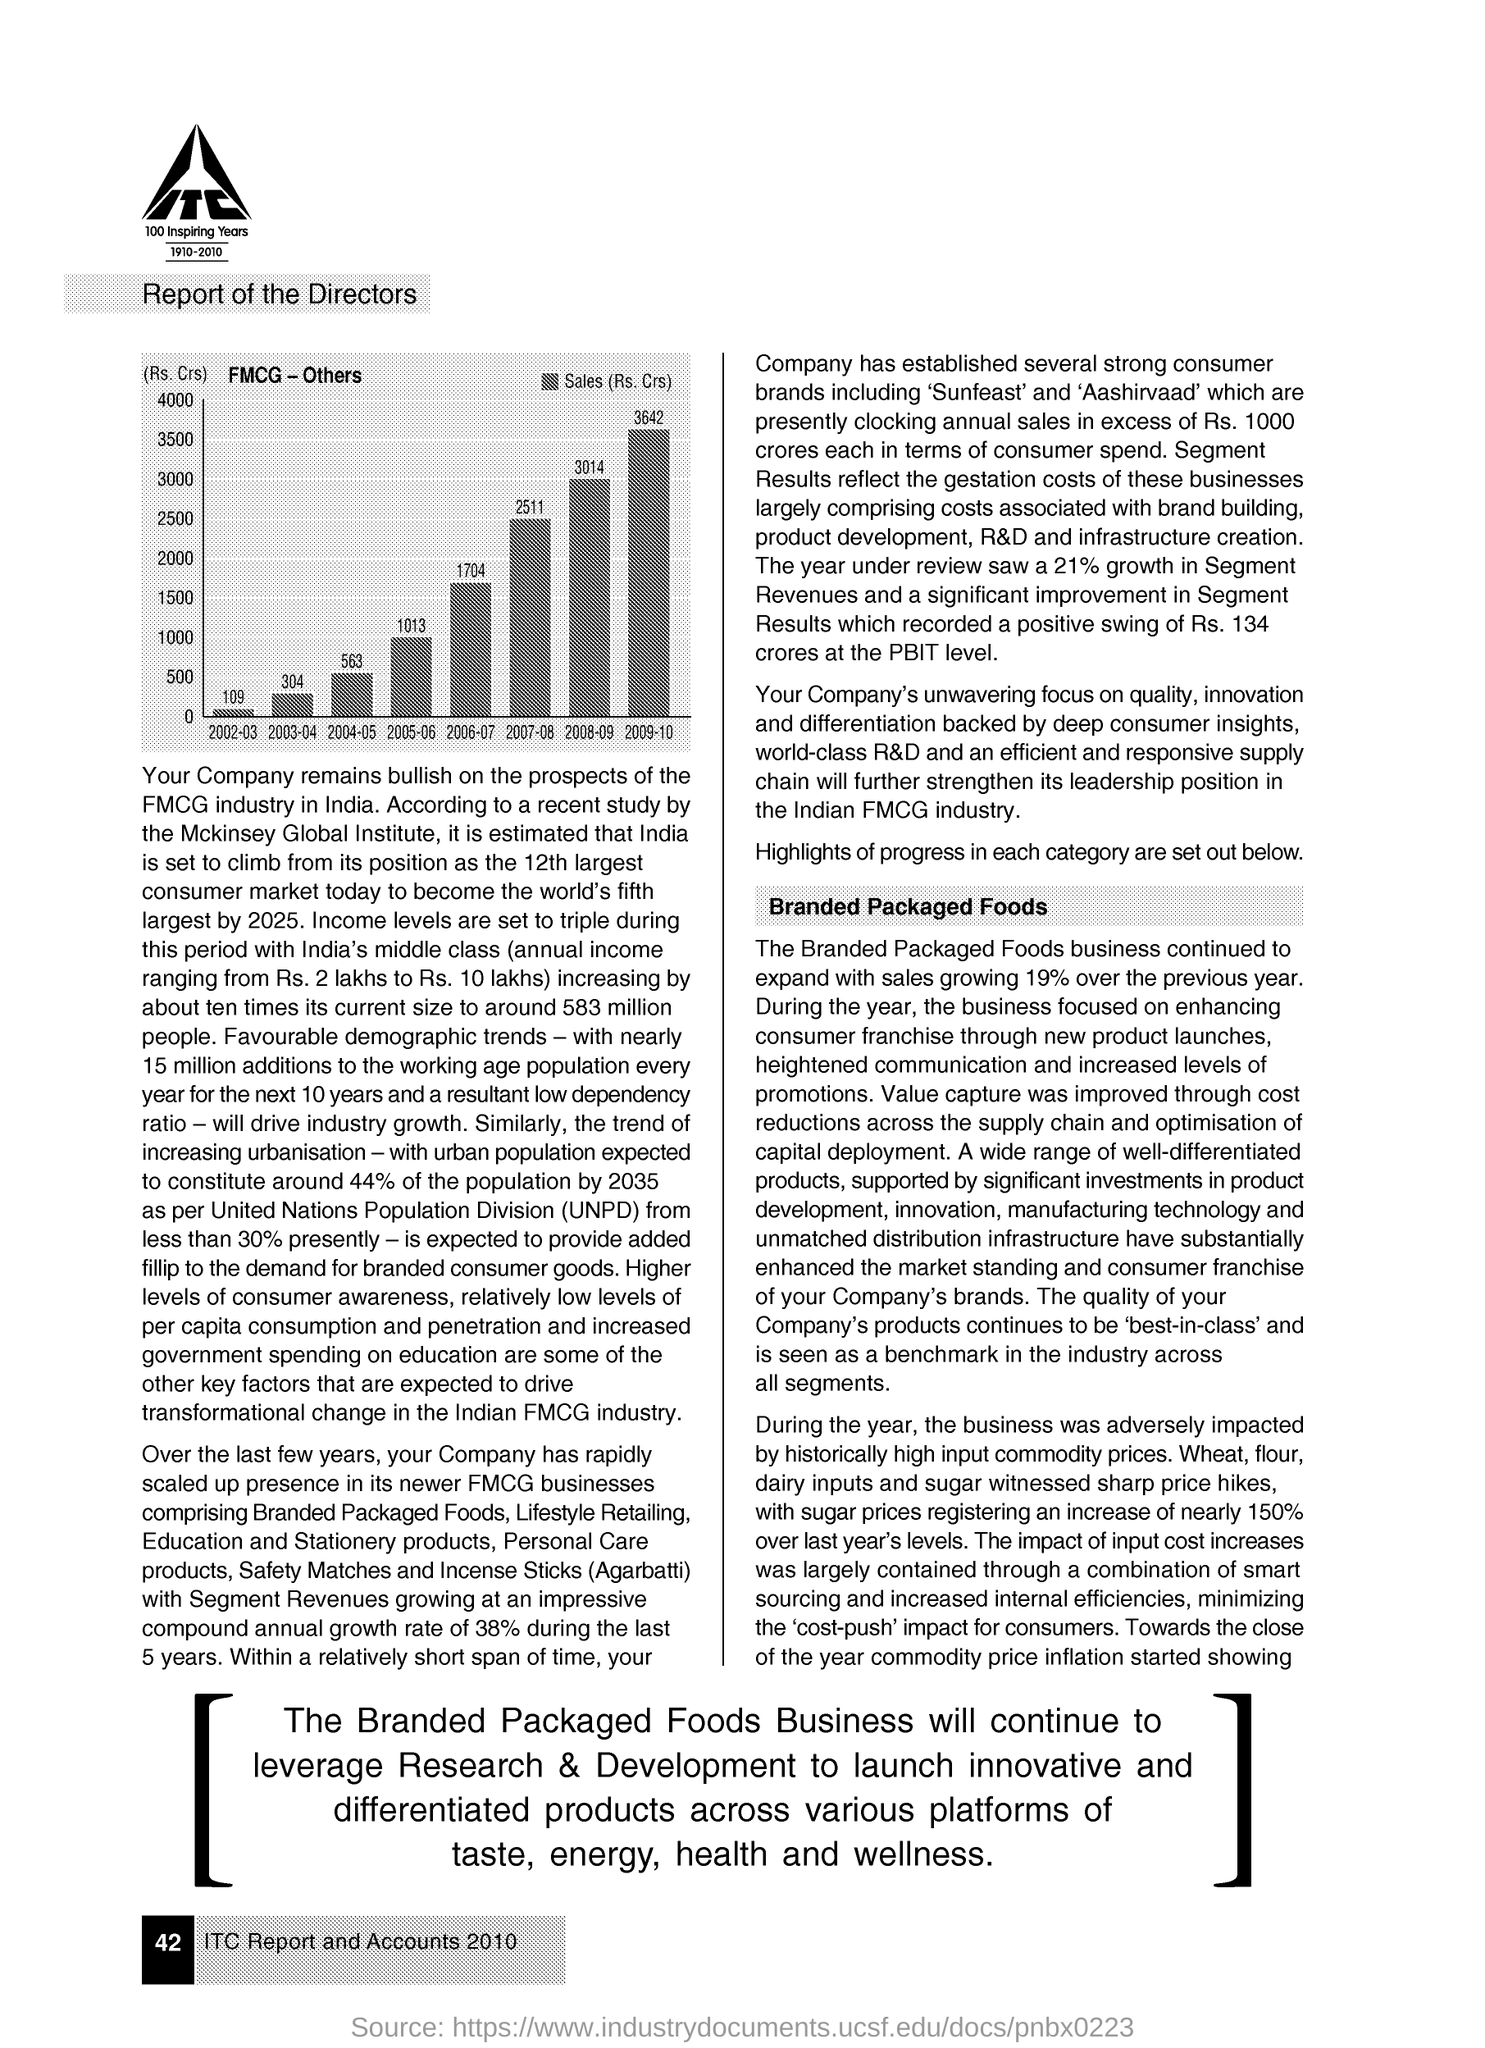Draw attention to some important aspects in this diagram. The amount of Sales for the year 2009-10 was Rs. 3642 crores. The sales in 2006-2007 were 1,704 crores. The graph shows the sales figures for a particular product over a period of time, and the year with the lowest sales is 2002-2003. The page number given at the left bottom of the page is 42. The logo, located in the left top corner of the page, contains the text 'ITC'. 